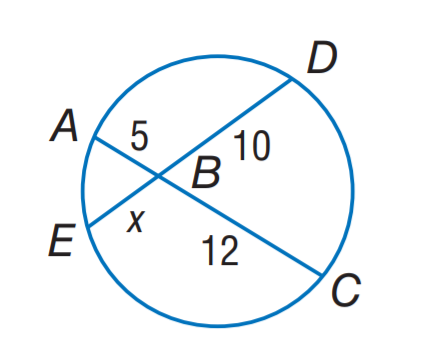Answer the mathemtical geometry problem and directly provide the correct option letter.
Question: Find x.
Choices: A: 5 B: 6 C: 10 D: 12 B 